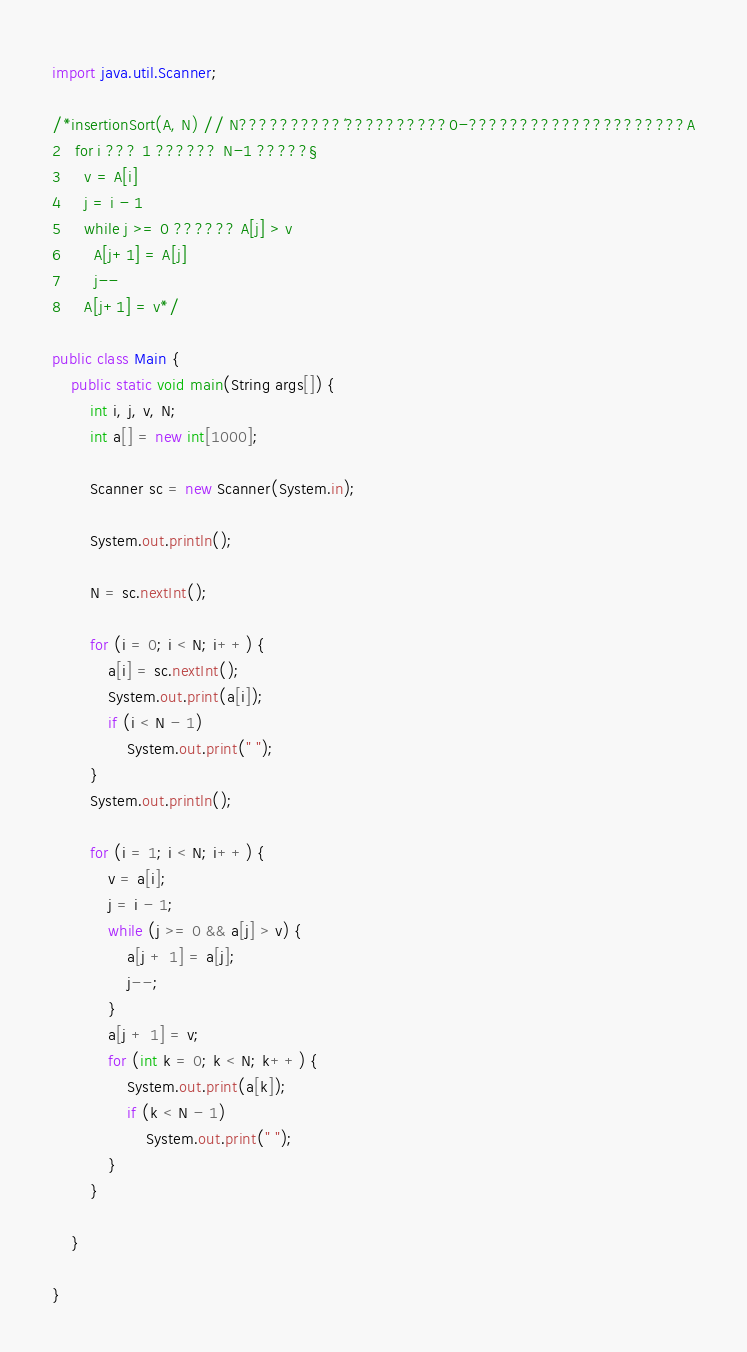<code> <loc_0><loc_0><loc_500><loc_500><_Java_>import java.util.Scanner;

/*insertionSort(A, N) // N??????????´??????????0-?????????????????????A
2   for i ??? 1 ?????? N-1 ?????§
3     v = A[i]
4     j = i - 1
5     while j >= 0 ?????? A[j] > v
6       A[j+1] = A[j]
7       j--
8     A[j+1] = v*/

public class Main {
	public static void main(String args[]) {
		int i, j, v, N;
		int a[] = new int[1000];

		Scanner sc = new Scanner(System.in);

		System.out.println();

		N = sc.nextInt();

		for (i = 0; i < N; i++) {
			a[i] = sc.nextInt();
			System.out.print(a[i]);
			if (i < N - 1)
				System.out.print(" ");
		}
		System.out.println();

		for (i = 1; i < N; i++) {
			v = a[i];
			j = i - 1;
			while (j >= 0 && a[j] > v) {
				a[j + 1] = a[j];
				j--;
			}
			a[j + 1] = v;
			for (int k = 0; k < N; k++) {
				System.out.print(a[k]);
				if (k < N - 1)
					System.out.print(" ");
			}
		}

	}

}</code> 